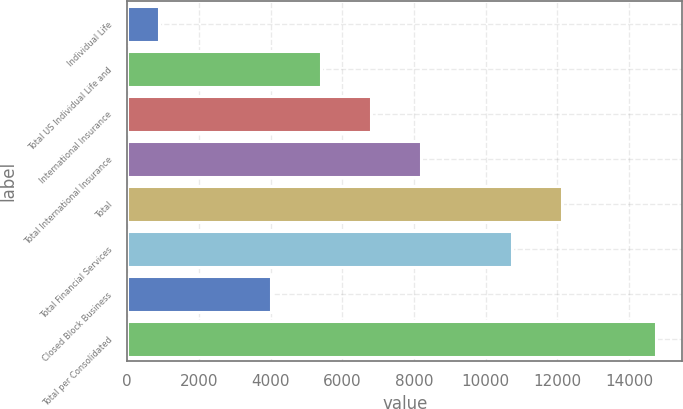Convert chart. <chart><loc_0><loc_0><loc_500><loc_500><bar_chart><fcel>Individual Life<fcel>Total US Individual Life and<fcel>International Insurance<fcel>Total International Insurance<fcel>Total<fcel>Total Financial Services<fcel>Closed Block Business<fcel>Total per Consolidated<nl><fcel>881<fcel>5407.8<fcel>6794.6<fcel>8181.4<fcel>12114.8<fcel>10728<fcel>4021<fcel>14749<nl></chart> 